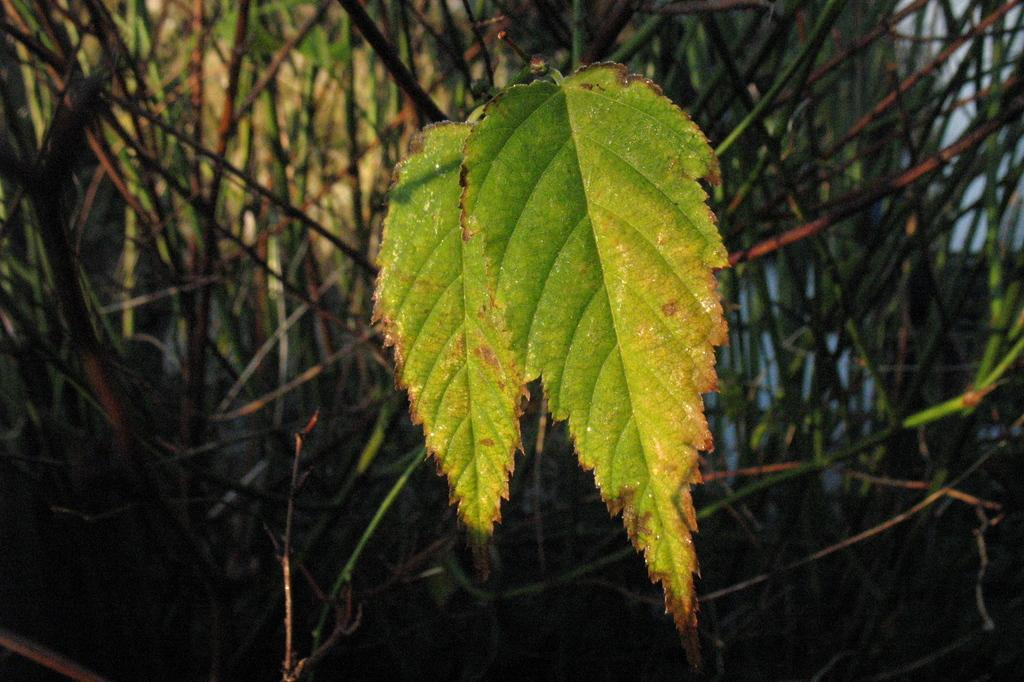What type of vegetation is visible in the front of the image? There are leaves in the front of the image. What can be seen in the background of the image? There are branches of plants in the background of the image. What type of drug is being used by the partner on the bike in the image? There is no bike, partner, or drug present in the image. The image only features leaves in the front and branches of plants in the background. 